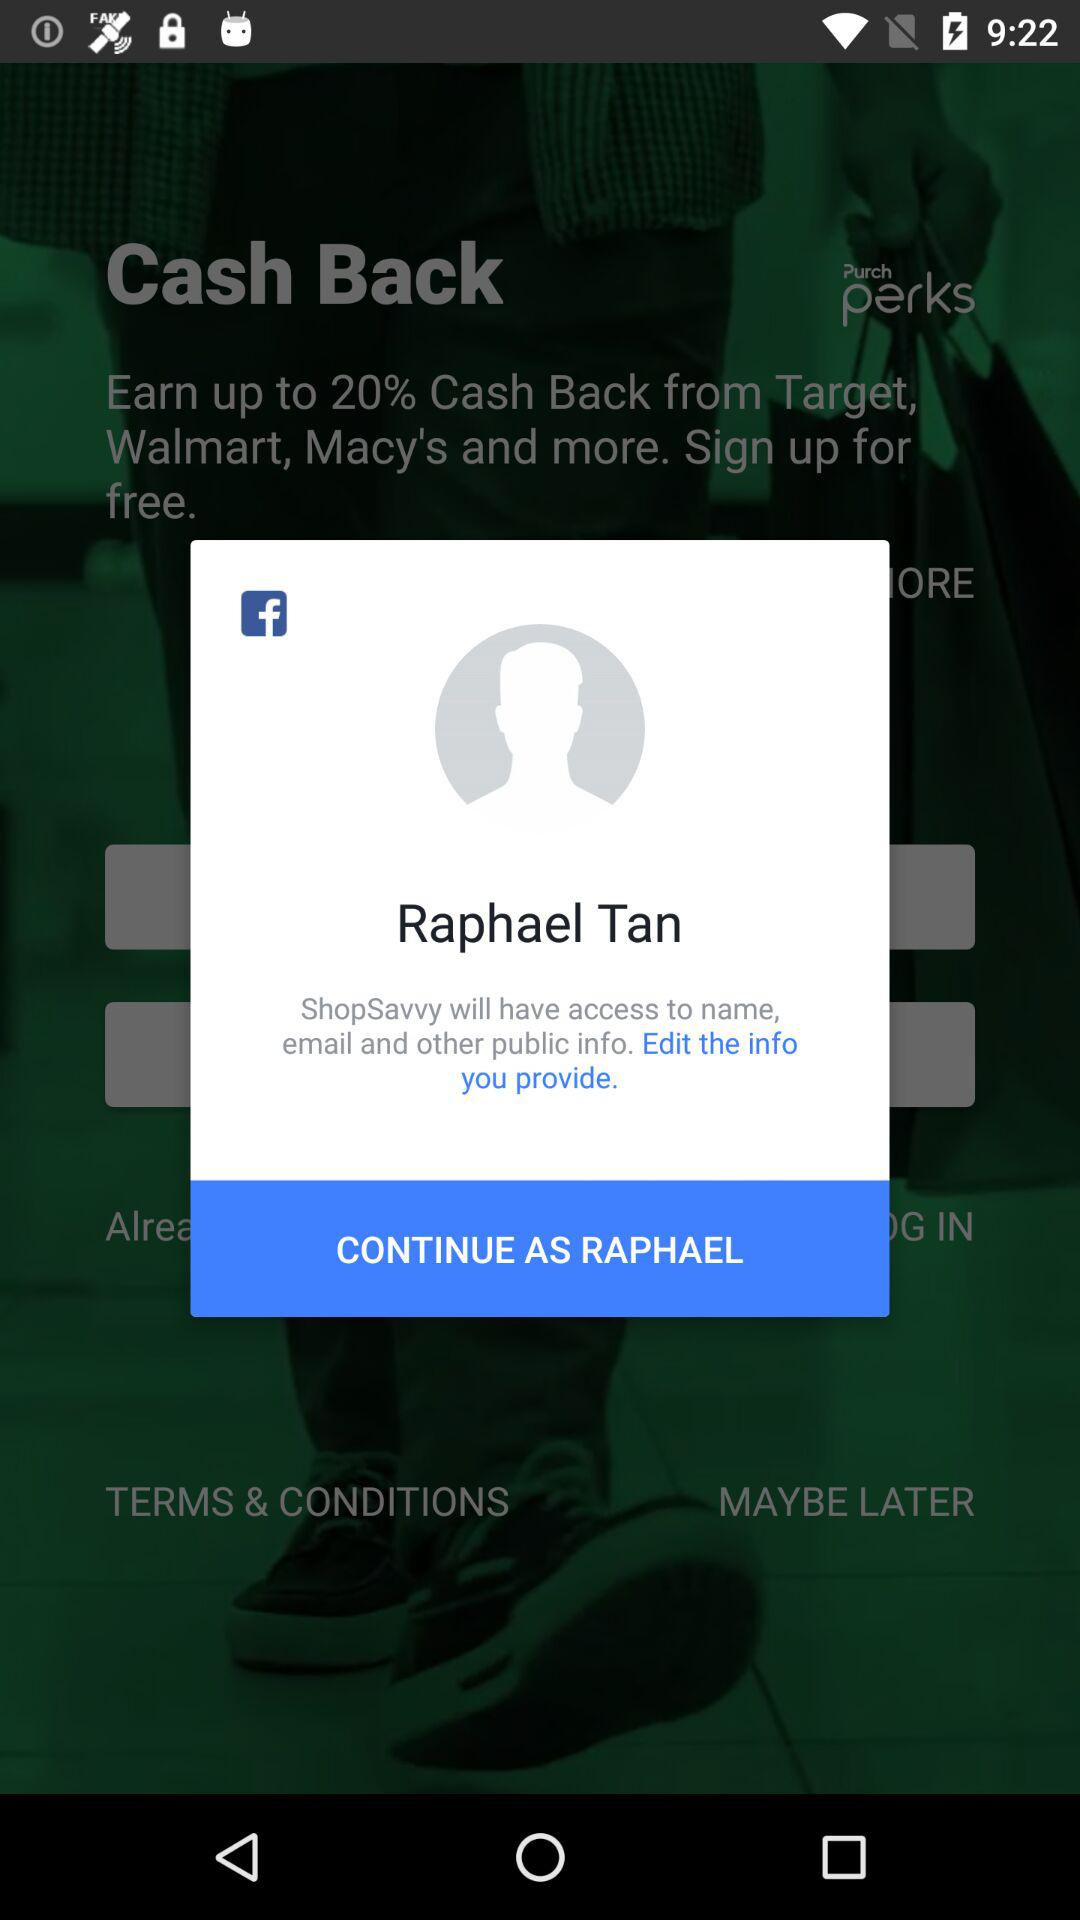What is the login name? The login name is Raphael Tan. 